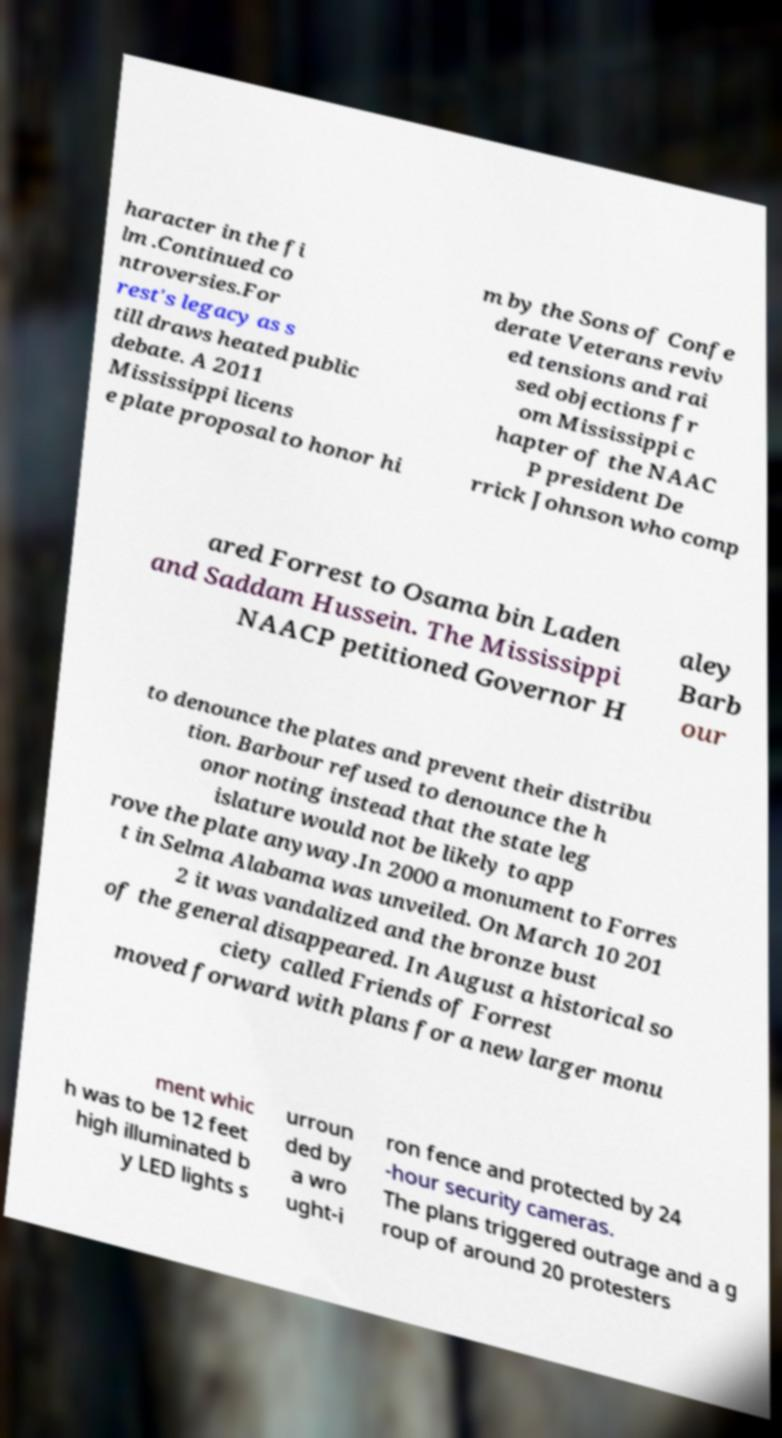I need the written content from this picture converted into text. Can you do that? haracter in the fi lm .Continued co ntroversies.For rest's legacy as s till draws heated public debate. A 2011 Mississippi licens e plate proposal to honor hi m by the Sons of Confe derate Veterans reviv ed tensions and rai sed objections fr om Mississippi c hapter of the NAAC P president De rrick Johnson who comp ared Forrest to Osama bin Laden and Saddam Hussein. The Mississippi NAACP petitioned Governor H aley Barb our to denounce the plates and prevent their distribu tion. Barbour refused to denounce the h onor noting instead that the state leg islature would not be likely to app rove the plate anyway.In 2000 a monument to Forres t in Selma Alabama was unveiled. On March 10 201 2 it was vandalized and the bronze bust of the general disappeared. In August a historical so ciety called Friends of Forrest moved forward with plans for a new larger monu ment whic h was to be 12 feet high illuminated b y LED lights s urroun ded by a wro ught-i ron fence and protected by 24 -hour security cameras. The plans triggered outrage and a g roup of around 20 protesters 